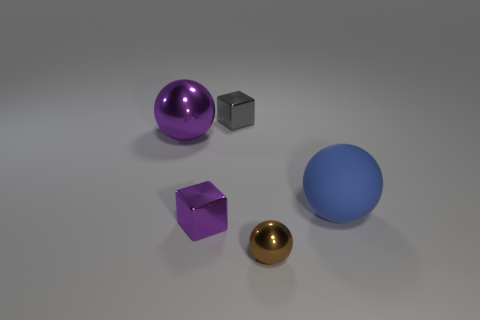Subtract all large balls. How many balls are left? 1 Subtract 1 cubes. How many cubes are left? 1 Subtract all blue balls. How many balls are left? 2 Subtract all yellow balls. How many green blocks are left? 0 Subtract all cyan balls. Subtract all purple cylinders. How many balls are left? 3 Subtract all large cyan blocks. Subtract all small gray metallic blocks. How many objects are left? 4 Add 4 tiny gray cubes. How many tiny gray cubes are left? 5 Add 4 tiny shiny balls. How many tiny shiny balls exist? 5 Add 5 small red rubber cylinders. How many objects exist? 10 Subtract 0 green cubes. How many objects are left? 5 